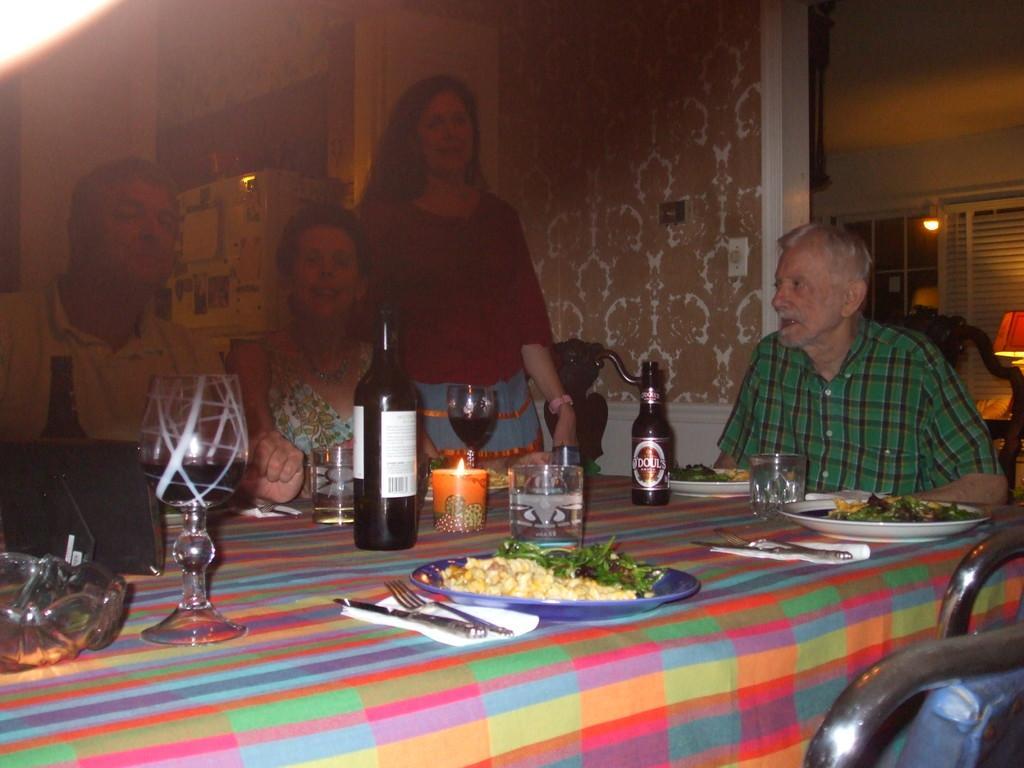Could you give a brief overview of what you see in this image? There are four people in a room. There is a table. There is a bottle,plate,tissue,spoon,fork and food item on a table. We can see in background curtain ,lamp. 